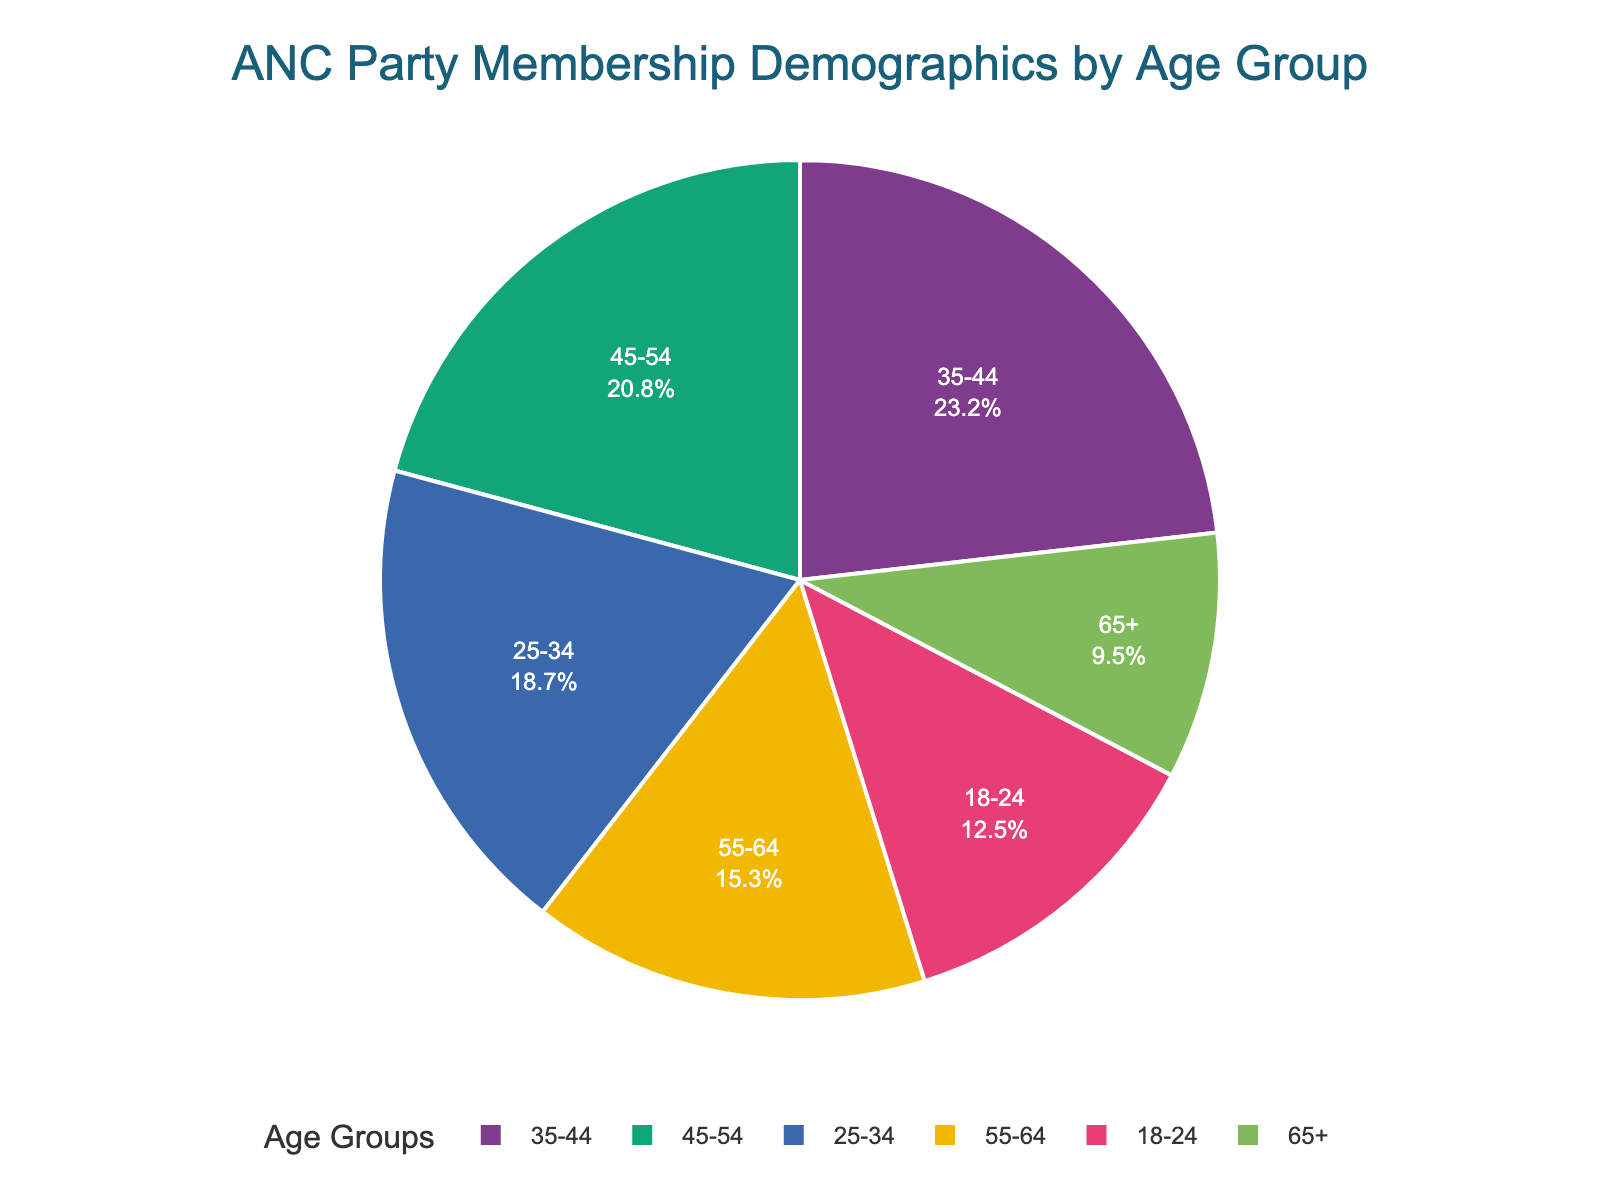What is the age group with the highest percentage of ANC members? To find the age group with the highest percentage of ANC members, look for the segment that has the largest portion of the pie chart. The '35-44' age group shows the largest slice.
Answer: 35-44 Which age group has the smallest percentage of ANC members? Assess the pie chart and identify the age group that occupies the smallest segment. The age group '65+' has the least percentage, which is the smallest segment.
Answer: 65+ How much higher is the percentage of ANC members aged 35-44 compared to those aged 55-64? Subtract the percentage of members aged '55-64' (15.3%) from those aged '35-44' (23.2%). The difference is 23.2% - 15.3% = 7.9%.
Answer: 7.9% What is the combined percentage of ANC members aged 18-24 and 25-34? Add together the percentage of members aged '18-24' (12.5%) and '25-34' (18.7%). The combined percentage is 12.5% + 18.7% = 31.2%.
Answer: 31.2% Is the percentage of ANC members aged 45-54 greater than those aged 55-64? Compare the two segments. The '45-54' age group has 20.8%, while the '55-64' group has 15.3%. Since 20.8% is greater than 15.3%, the answer is yes.
Answer: Yes What is the percentage difference between the oldest age group (65+) and the youngest age group (18-24)? Subtract the percentage of the '65+' group (9.5%) from the '18-24' group (12.5%). The difference is 12.5% - 9.5% = 3%.
Answer: 3% Which age group is represented by the third largest segment in the pie chart? Arrange the percentages in descending order and identify the third highest: 23.2% (35-44), 20.8% (45-54), 18.7% (25-34). The third largest is '25-34'.
Answer: 25-34 